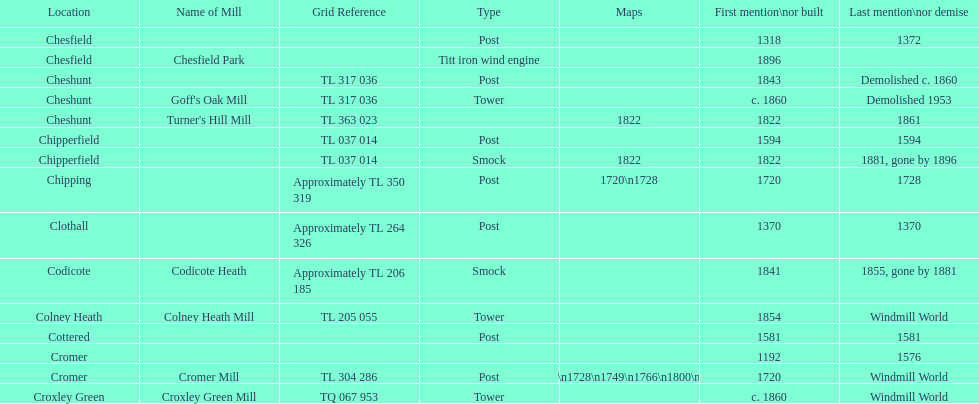How many mills were mentioned or built before 1700? 5. 